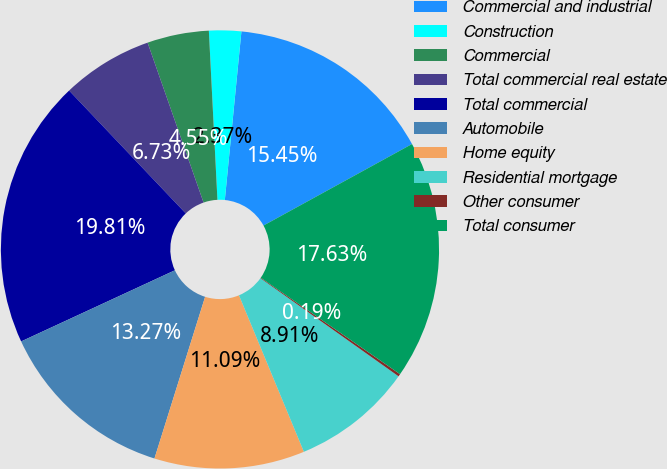<chart> <loc_0><loc_0><loc_500><loc_500><pie_chart><fcel>Commercial and industrial<fcel>Construction<fcel>Commercial<fcel>Total commercial real estate<fcel>Total commercial<fcel>Automobile<fcel>Home equity<fcel>Residential mortgage<fcel>Other consumer<fcel>Total consumer<nl><fcel>15.45%<fcel>2.37%<fcel>4.55%<fcel>6.73%<fcel>19.81%<fcel>13.27%<fcel>11.09%<fcel>8.91%<fcel>0.19%<fcel>17.63%<nl></chart> 